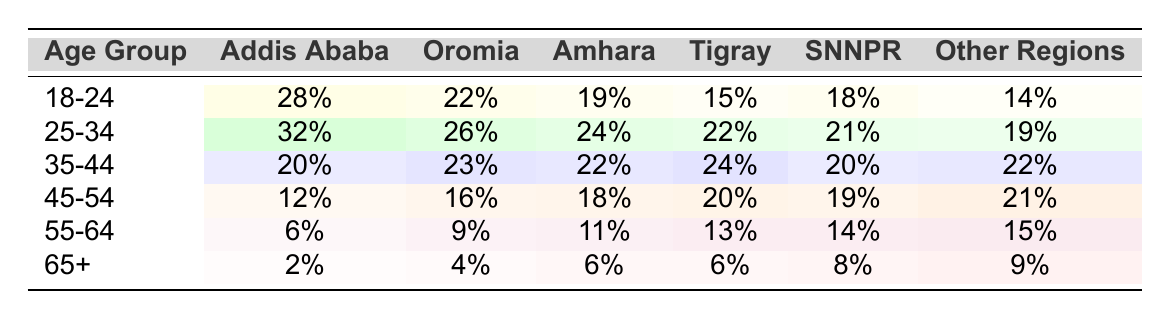What percentage of media consumers aged 18-24 are from Addis Ababa? Referring to the table, the percentage of media consumers aged 18-24 from Addis Ababa is directly listed as 28%.
Answer: 28% Which age group has the highest percentage of consumers in Oromia? By scanning the percentage values for Oromia, the age group 25-34 has the highest percentage at 26%.
Answer: 25-34 What is the percentage of media consumers aged 55-64 in Amhara? The table shows that the percentage of media consumers aged 55-64 in Amhara is 11%.
Answer: 11% Is the percentage of media consumers aged 65+ higher in SNNPR than in Oromia? Looking at the values, SNNPR has 8% while Oromia has 4%, thus the percentage in SNNPR is higher, making the statement true.
Answer: Yes What is the average percentage of media consumers aged 35-44 across all regions? The percentages for 35-44 across regions are 20%, 23%, 22%, 24%, 20%, and 22%. Summing these values gives 131%, and dividing by 6 (the number of regions) gives an average of approximately 21.83%.
Answer: 21.83% How many percentage points more do media consumers aged 25-34 in Addis Ababa than in Tigray? The percentage for Addis Ababa is 32% and for Tigray is 22%. The difference is 32% - 22% = 10 percentage points.
Answer: 10 Are there more consumers aged 45-54 in Other Regions compared to Amhara? Comparing the percentages, Other Regions has 21% while Amhara has 18%. Since 21% is greater than 18%, the answer is true.
Answer: Yes What age group has the lowest percentage of media consumers in Tigray? In Tigray, the lowest percentage listed is for the age group 65+, which has 6%.
Answer: 65+ What is the total percentage of media consumers aged 18-24 across all regions? Adding the percentages for the age group 18-24 gives 28% + 22% + 19% + 15% + 18% + 14% = 116%.
Answer: 116% Which age group in SNNPR has the closest percentage to that in Addis Ababa? In SNNPR, the age group 25-34 has 21% and in Addis Ababa, the same age group has 32%. The difference is 11 percentage points, which is the smallest comparison found, making this age group the closest.
Answer: 25-34 